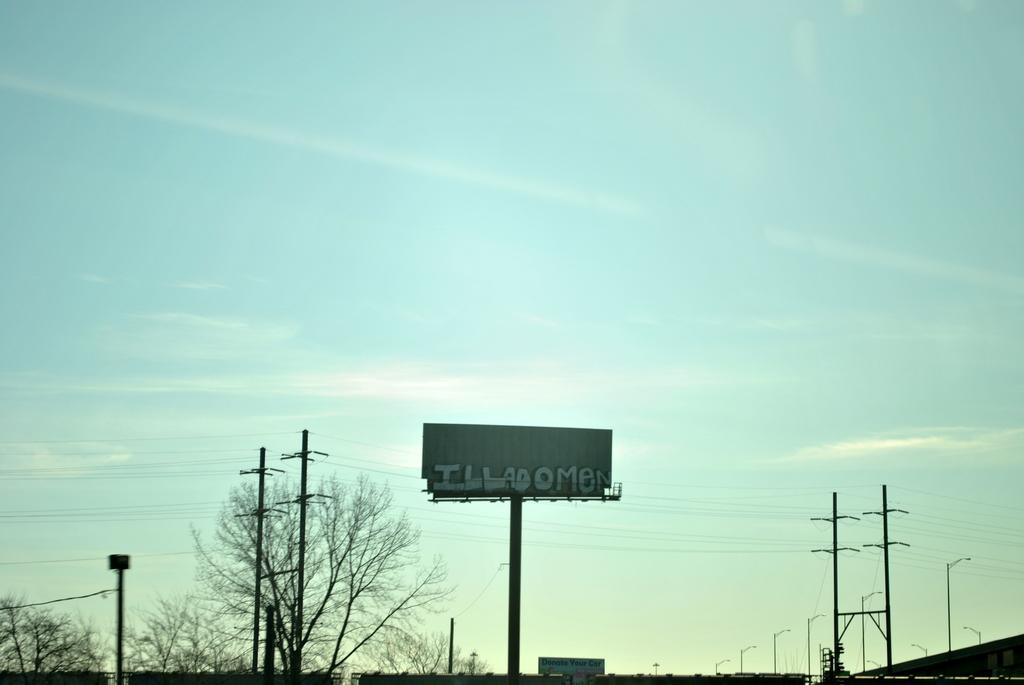What does the billboard say?
Your response must be concise. Illadomen. 